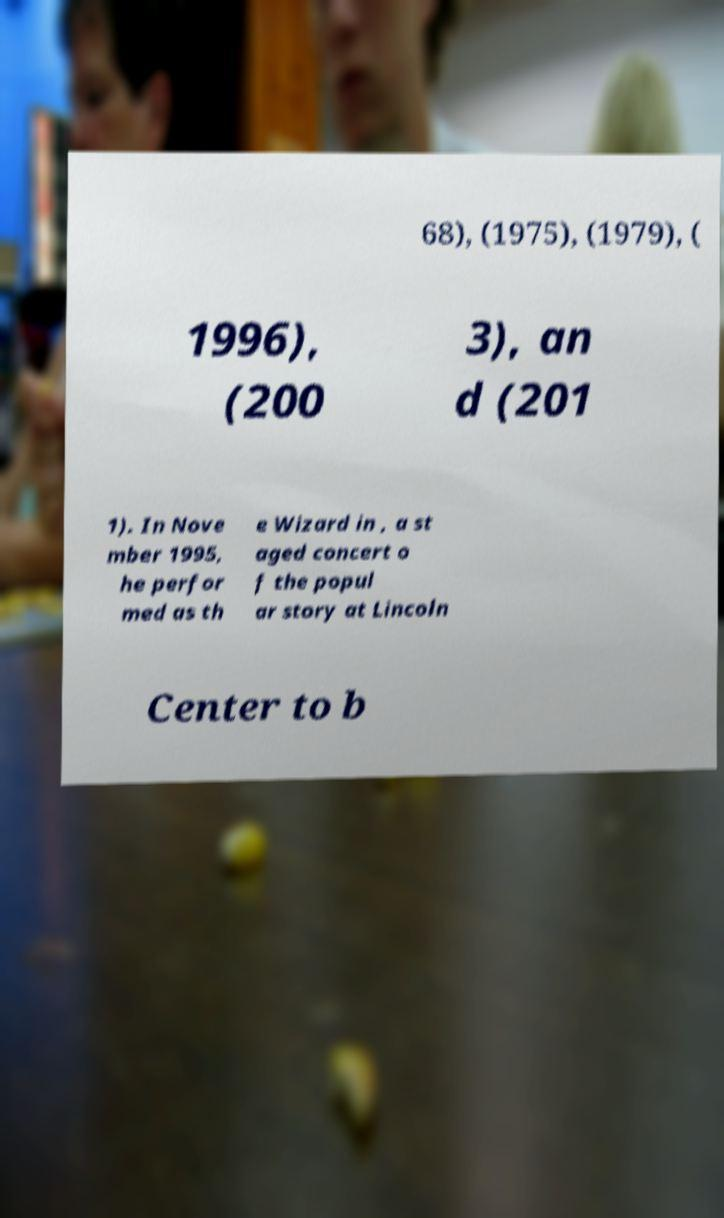Please read and relay the text visible in this image. What does it say? 68), (1975), (1979), ( 1996), (200 3), an d (201 1). In Nove mber 1995, he perfor med as th e Wizard in , a st aged concert o f the popul ar story at Lincoln Center to b 